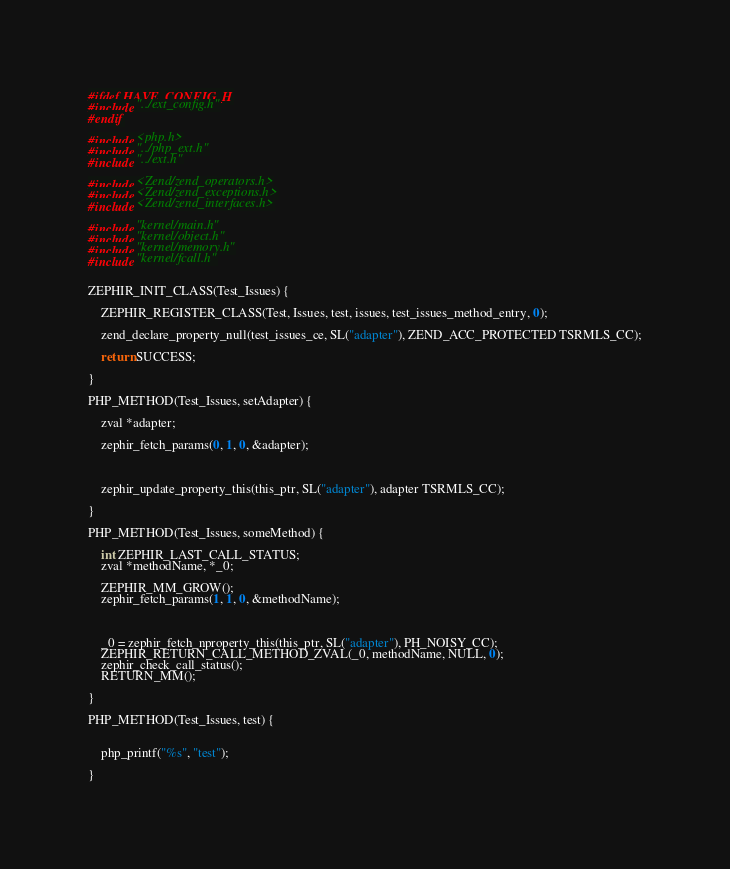<code> <loc_0><loc_0><loc_500><loc_500><_C_>
#ifdef HAVE_CONFIG_H
#include "../ext_config.h"
#endif

#include <php.h>
#include "../php_ext.h"
#include "../ext.h"

#include <Zend/zend_operators.h>
#include <Zend/zend_exceptions.h>
#include <Zend/zend_interfaces.h>

#include "kernel/main.h"
#include "kernel/object.h"
#include "kernel/memory.h"
#include "kernel/fcall.h"


ZEPHIR_INIT_CLASS(Test_Issues) {

	ZEPHIR_REGISTER_CLASS(Test, Issues, test, issues, test_issues_method_entry, 0);

	zend_declare_property_null(test_issues_ce, SL("adapter"), ZEND_ACC_PROTECTED TSRMLS_CC);

	return SUCCESS;

}

PHP_METHOD(Test_Issues, setAdapter) {

	zval *adapter;

	zephir_fetch_params(0, 1, 0, &adapter);



	zephir_update_property_this(this_ptr, SL("adapter"), adapter TSRMLS_CC);

}

PHP_METHOD(Test_Issues, someMethod) {

	int ZEPHIR_LAST_CALL_STATUS;
	zval *methodName, *_0;

	ZEPHIR_MM_GROW();
	zephir_fetch_params(1, 1, 0, &methodName);



	_0 = zephir_fetch_nproperty_this(this_ptr, SL("adapter"), PH_NOISY_CC);
	ZEPHIR_RETURN_CALL_METHOD_ZVAL(_0, methodName, NULL, 0);
	zephir_check_call_status();
	RETURN_MM();

}

PHP_METHOD(Test_Issues, test) {


	php_printf("%s", "test");

}

</code> 